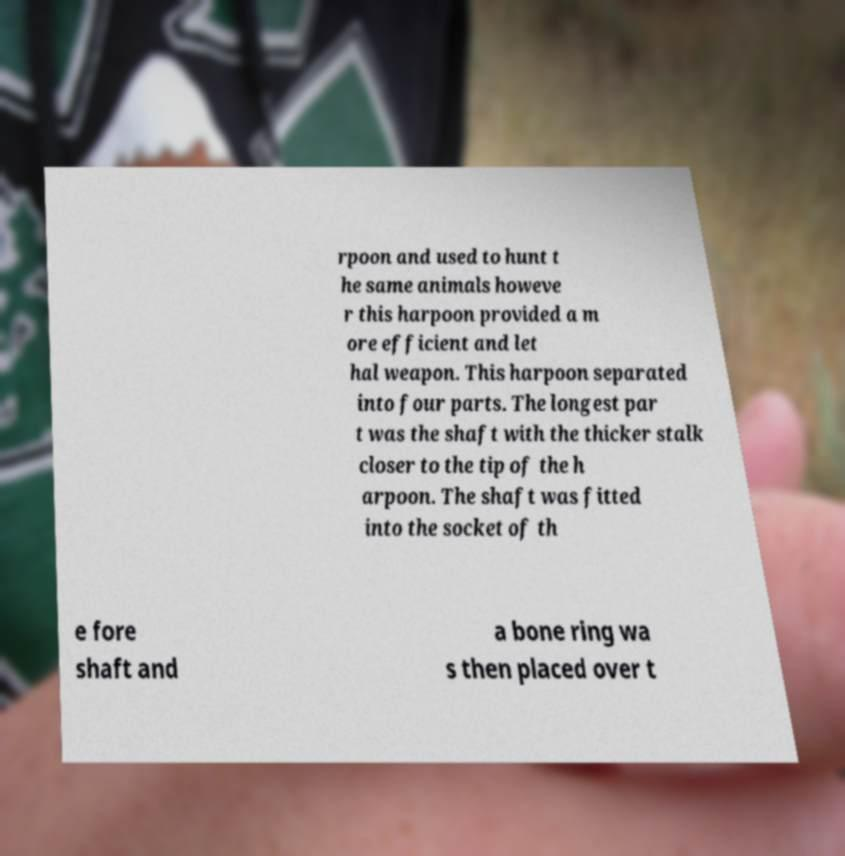Can you accurately transcribe the text from the provided image for me? rpoon and used to hunt t he same animals howeve r this harpoon provided a m ore efficient and let hal weapon. This harpoon separated into four parts. The longest par t was the shaft with the thicker stalk closer to the tip of the h arpoon. The shaft was fitted into the socket of th e fore shaft and a bone ring wa s then placed over t 